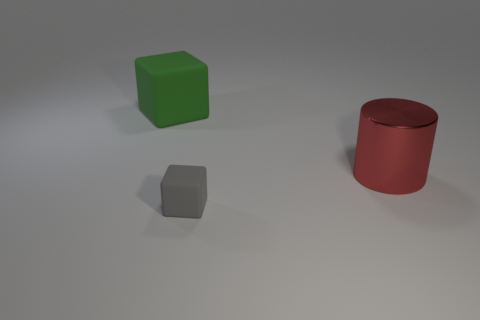Add 2 blue matte blocks. How many objects exist? 5 Subtract all cylinders. How many objects are left? 2 Add 2 big things. How many big things are left? 4 Add 3 red metallic cylinders. How many red metallic cylinders exist? 4 Subtract 0 blue balls. How many objects are left? 3 Subtract all red cylinders. Subtract all big cubes. How many objects are left? 1 